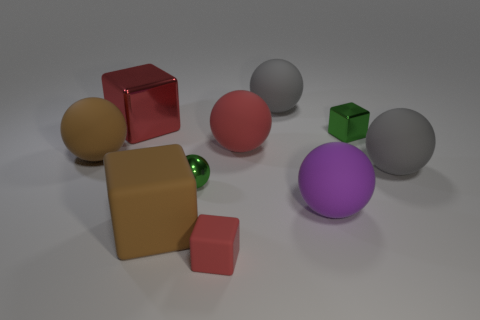Subtract all brown spheres. How many spheres are left? 5 Subtract all green spheres. How many spheres are left? 5 Subtract 1 spheres. How many spheres are left? 5 Subtract all brown balls. Subtract all gray cubes. How many balls are left? 5 Subtract all cubes. How many objects are left? 6 Add 8 small yellow metal objects. How many small yellow metal objects exist? 8 Subtract 0 yellow cylinders. How many objects are left? 10 Subtract all yellow rubber cylinders. Subtract all red matte spheres. How many objects are left? 9 Add 9 tiny rubber objects. How many tiny rubber objects are left? 10 